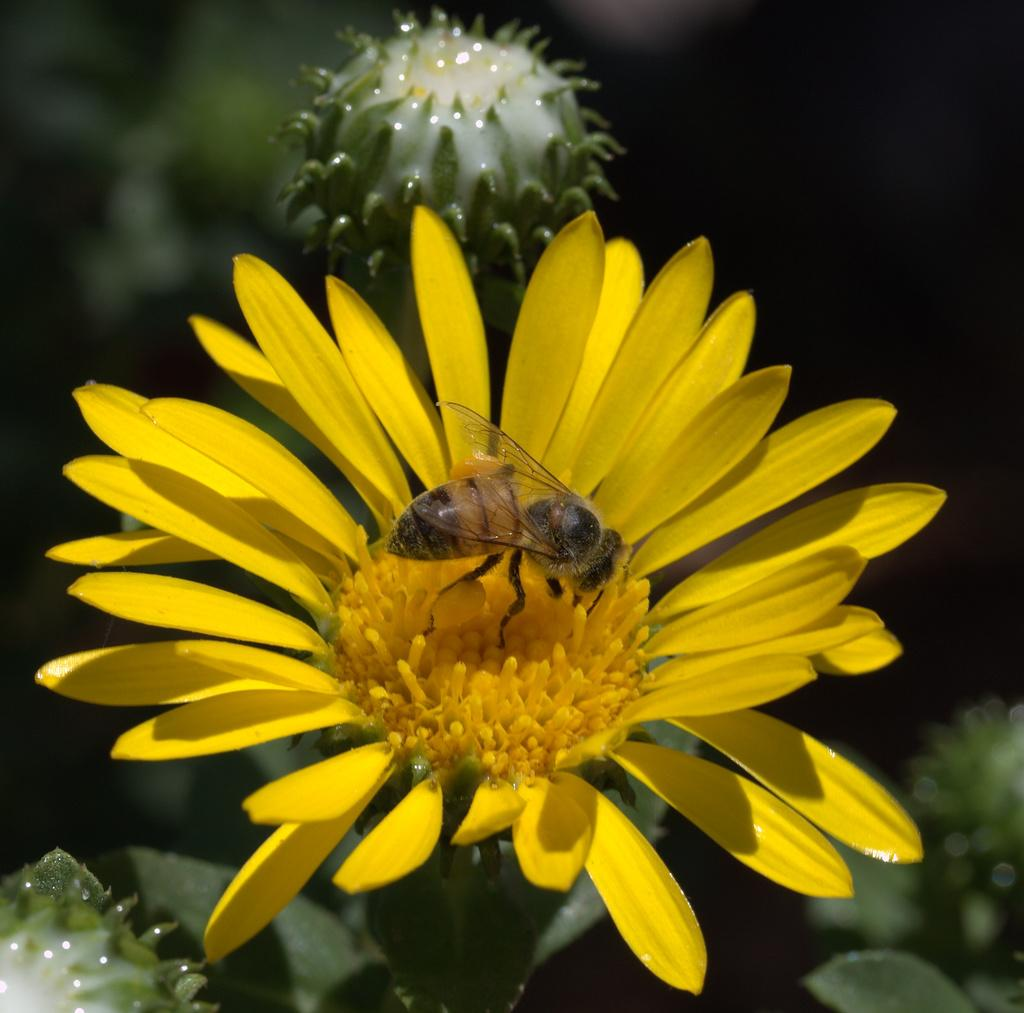What is the main subject in the middle of the image? There are flowers in the middle of the image. Is there anything else present on the flowers? Yes, there is an insect on the flowers. How would you describe the background of the image? The background of the image is blurred. What type of leather is visible on the string in the image? There is no string or leather present in the image. 